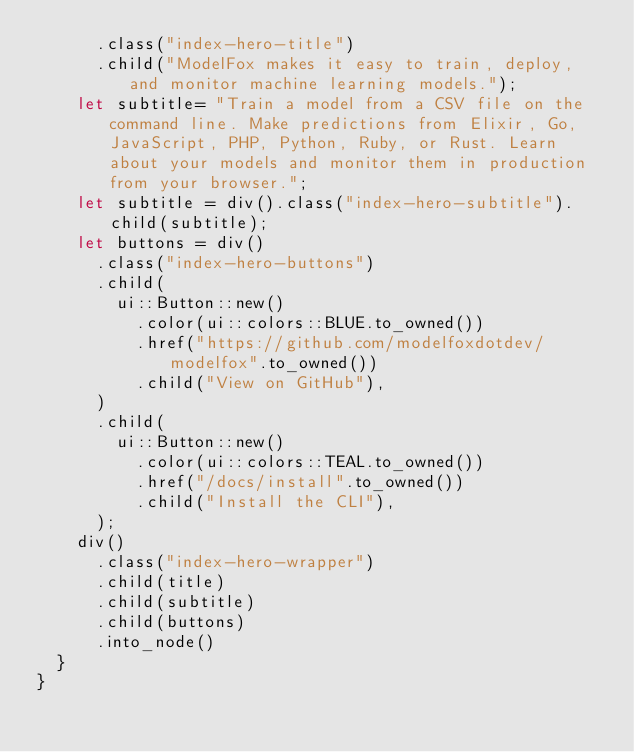<code> <loc_0><loc_0><loc_500><loc_500><_Rust_>			.class("index-hero-title")
			.child("ModelFox makes it easy to train, deploy, and monitor machine learning models.");
		let subtitle= "Train a model from a CSV file on the command line. Make predictions from Elixir, Go, JavaScript, PHP, Python, Ruby, or Rust. Learn about your models and monitor them in production from your browser.";
		let subtitle = div().class("index-hero-subtitle").child(subtitle);
		let buttons = div()
			.class("index-hero-buttons")
			.child(
				ui::Button::new()
					.color(ui::colors::BLUE.to_owned())
					.href("https://github.com/modelfoxdotdev/modelfox".to_owned())
					.child("View on GitHub"),
			)
			.child(
				ui::Button::new()
					.color(ui::colors::TEAL.to_owned())
					.href("/docs/install".to_owned())
					.child("Install the CLI"),
			);
		div()
			.class("index-hero-wrapper")
			.child(title)
			.child(subtitle)
			.child(buttons)
			.into_node()
	}
}
</code> 